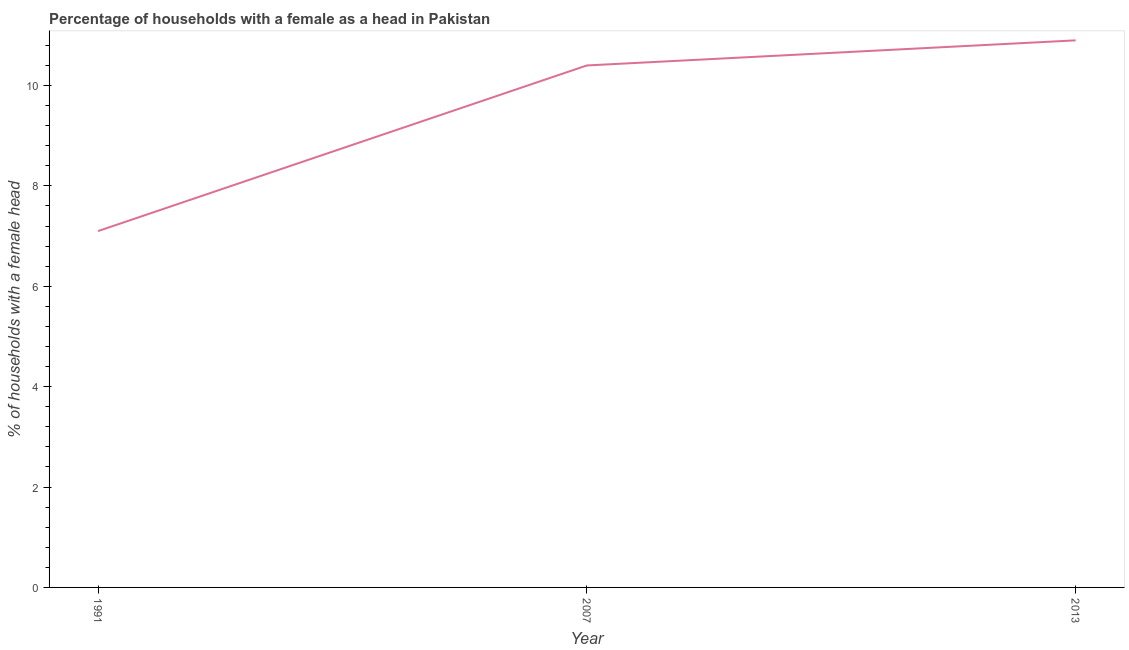What is the number of female supervised households in 2007?
Keep it short and to the point. 10.4. Across all years, what is the maximum number of female supervised households?
Keep it short and to the point. 10.9. Across all years, what is the minimum number of female supervised households?
Offer a very short reply. 7.1. In which year was the number of female supervised households maximum?
Offer a very short reply. 2013. In which year was the number of female supervised households minimum?
Make the answer very short. 1991. What is the sum of the number of female supervised households?
Provide a short and direct response. 28.4. What is the difference between the number of female supervised households in 1991 and 2007?
Offer a terse response. -3.3. What is the average number of female supervised households per year?
Your answer should be compact. 9.47. Do a majority of the years between 2007 and 1991 (inclusive) have number of female supervised households greater than 4.4 %?
Give a very brief answer. No. What is the ratio of the number of female supervised households in 2007 to that in 2013?
Offer a terse response. 0.95. What is the difference between the highest and the second highest number of female supervised households?
Offer a very short reply. 0.5. Is the sum of the number of female supervised households in 1991 and 2013 greater than the maximum number of female supervised households across all years?
Offer a terse response. Yes. What is the difference between the highest and the lowest number of female supervised households?
Ensure brevity in your answer.  3.8. What is the difference between two consecutive major ticks on the Y-axis?
Offer a terse response. 2. Does the graph contain grids?
Provide a succinct answer. No. What is the title of the graph?
Ensure brevity in your answer.  Percentage of households with a female as a head in Pakistan. What is the label or title of the Y-axis?
Give a very brief answer. % of households with a female head. What is the % of households with a female head in 2013?
Provide a succinct answer. 10.9. What is the difference between the % of households with a female head in 1991 and 2007?
Your answer should be very brief. -3.3. What is the difference between the % of households with a female head in 1991 and 2013?
Provide a succinct answer. -3.8. What is the difference between the % of households with a female head in 2007 and 2013?
Provide a succinct answer. -0.5. What is the ratio of the % of households with a female head in 1991 to that in 2007?
Offer a very short reply. 0.68. What is the ratio of the % of households with a female head in 1991 to that in 2013?
Your answer should be compact. 0.65. What is the ratio of the % of households with a female head in 2007 to that in 2013?
Ensure brevity in your answer.  0.95. 